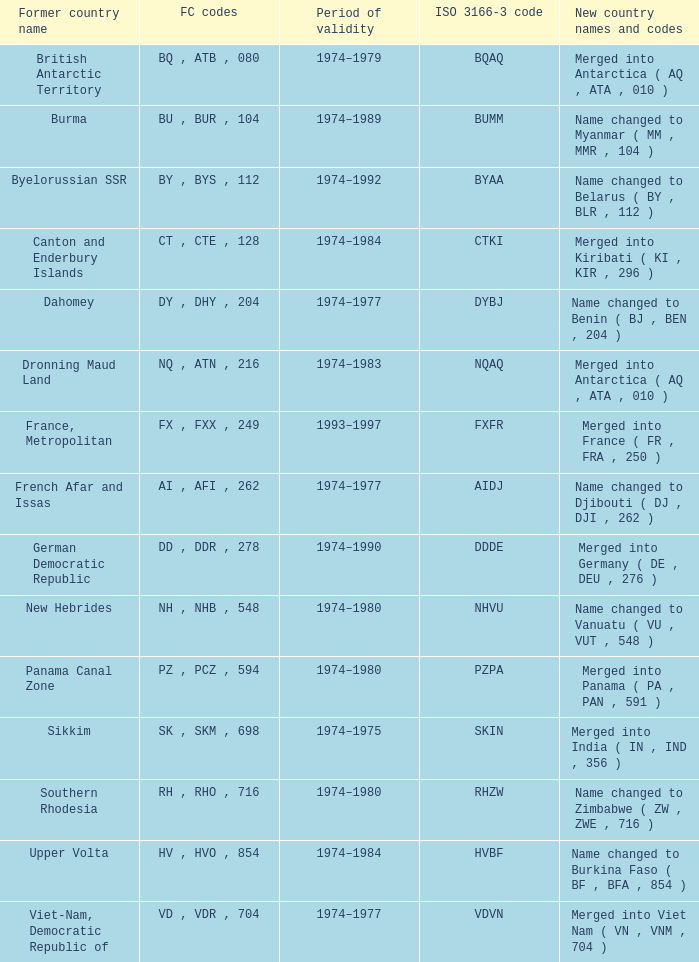Help me parse the entirety of this table. {'header': ['Former country name', 'FC codes', 'Period of validity', 'ISO 3166-3 code', 'New country names and codes'], 'rows': [['British Antarctic Territory', 'BQ , ATB , 080', '1974–1979', 'BQAQ', 'Merged into Antarctica ( AQ , ATA , 010 )'], ['Burma', 'BU , BUR , 104', '1974–1989', 'BUMM', 'Name changed to Myanmar ( MM , MMR , 104 )'], ['Byelorussian SSR', 'BY , BYS , 112', '1974–1992', 'BYAA', 'Name changed to Belarus ( BY , BLR , 112 )'], ['Canton and Enderbury Islands', 'CT , CTE , 128', '1974–1984', 'CTKI', 'Merged into Kiribati ( KI , KIR , 296 )'], ['Dahomey', 'DY , DHY , 204', '1974–1977', 'DYBJ', 'Name changed to Benin ( BJ , BEN , 204 )'], ['Dronning Maud Land', 'NQ , ATN , 216', '1974–1983', 'NQAQ', 'Merged into Antarctica ( AQ , ATA , 010 )'], ['France, Metropolitan', 'FX , FXX , 249', '1993–1997', 'FXFR', 'Merged into France ( FR , FRA , 250 )'], ['French Afar and Issas', 'AI , AFI , 262', '1974–1977', 'AIDJ', 'Name changed to Djibouti ( DJ , DJI , 262 )'], ['German Democratic Republic', 'DD , DDR , 278', '1974–1990', 'DDDE', 'Merged into Germany ( DE , DEU , 276 )'], ['New Hebrides', 'NH , NHB , 548', '1974–1980', 'NHVU', 'Name changed to Vanuatu ( VU , VUT , 548 )'], ['Panama Canal Zone', 'PZ , PCZ , 594', '1974–1980', 'PZPA', 'Merged into Panama ( PA , PAN , 591 )'], ['Sikkim', 'SK , SKM , 698', '1974–1975', 'SKIN', 'Merged into India ( IN , IND , 356 )'], ['Southern Rhodesia', 'RH , RHO , 716', '1974–1980', 'RHZW', 'Name changed to Zimbabwe ( ZW , ZWE , 716 )'], ['Upper Volta', 'HV , HVO , 854', '1974–1984', 'HVBF', 'Name changed to Burkina Faso ( BF , BFA , 854 )'], ['Viet-Nam, Democratic Republic of', 'VD , VDR , 704', '1974–1977', 'VDVN', 'Merged into Viet Nam ( VN , VNM , 704 )']]} Name the former codes for  merged into panama ( pa , pan , 591 ) PZ , PCZ , 594. 